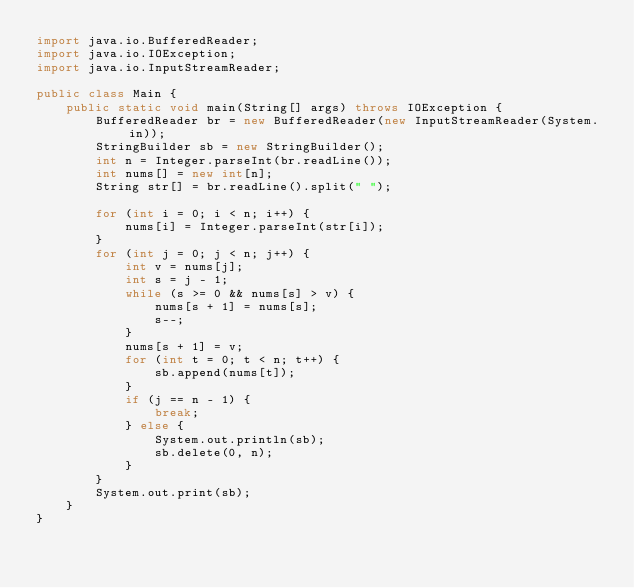Convert code to text. <code><loc_0><loc_0><loc_500><loc_500><_Java_>import java.io.BufferedReader;
import java.io.IOException;
import java.io.InputStreamReader;

public class Main {
	public static void main(String[] args) throws IOException {
		BufferedReader br = new BufferedReader(new InputStreamReader(System.in));
		StringBuilder sb = new StringBuilder();
		int n = Integer.parseInt(br.readLine());
		int nums[] = new int[n];
		String str[] = br.readLine().split(" ");

		for (int i = 0; i < n; i++) {
			nums[i] = Integer.parseInt(str[i]);
		}
		for (int j = 0; j < n; j++) {
			int v = nums[j];
			int s = j - 1;
			while (s >= 0 && nums[s] > v) {
				nums[s + 1] = nums[s];
				s--;
			}
			nums[s + 1] = v;
			for (int t = 0; t < n; t++) {
				sb.append(nums[t]);
			}
			if (j == n - 1) {
				break;
			} else {
				System.out.println(sb);
				sb.delete(0, n);
			}
		}
		System.out.print(sb);
	}
}</code> 